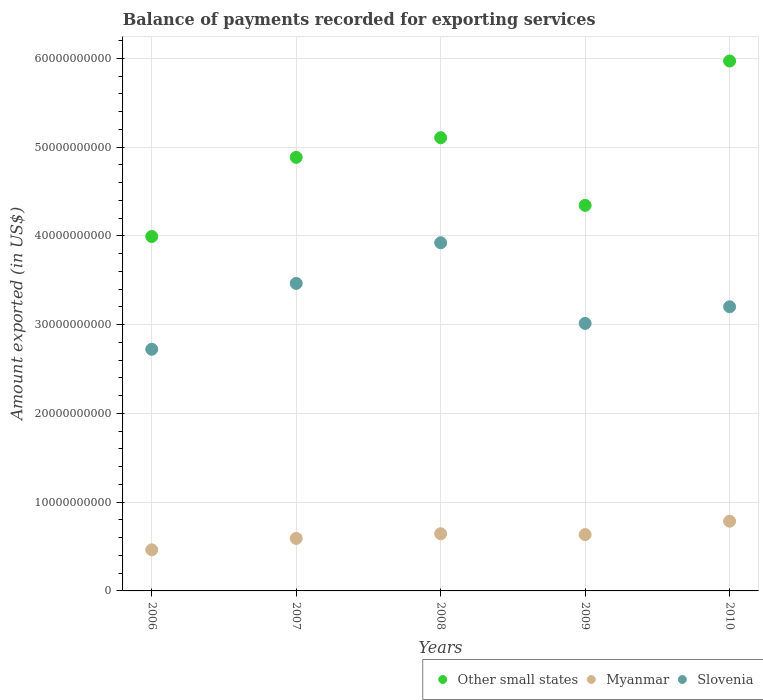Is the number of dotlines equal to the number of legend labels?
Make the answer very short. Yes. What is the amount exported in Myanmar in 2009?
Keep it short and to the point. 6.35e+09. Across all years, what is the maximum amount exported in Slovenia?
Give a very brief answer. 3.92e+1. Across all years, what is the minimum amount exported in Myanmar?
Offer a very short reply. 4.63e+09. What is the total amount exported in Myanmar in the graph?
Your answer should be compact. 3.12e+1. What is the difference between the amount exported in Other small states in 2008 and that in 2010?
Offer a terse response. -8.64e+09. What is the difference between the amount exported in Slovenia in 2009 and the amount exported in Other small states in 2007?
Your answer should be very brief. -1.87e+1. What is the average amount exported in Slovenia per year?
Your answer should be compact. 3.26e+1. In the year 2009, what is the difference between the amount exported in Other small states and amount exported in Myanmar?
Offer a very short reply. 3.71e+1. In how many years, is the amount exported in Other small states greater than 32000000000 US$?
Your answer should be compact. 5. What is the ratio of the amount exported in Myanmar in 2006 to that in 2007?
Keep it short and to the point. 0.78. Is the difference between the amount exported in Other small states in 2006 and 2007 greater than the difference between the amount exported in Myanmar in 2006 and 2007?
Your answer should be very brief. No. What is the difference between the highest and the second highest amount exported in Slovenia?
Make the answer very short. 4.58e+09. What is the difference between the highest and the lowest amount exported in Other small states?
Your answer should be compact. 1.98e+1. In how many years, is the amount exported in Slovenia greater than the average amount exported in Slovenia taken over all years?
Provide a succinct answer. 2. Does the amount exported in Myanmar monotonically increase over the years?
Your response must be concise. No. Is the amount exported in Slovenia strictly greater than the amount exported in Myanmar over the years?
Offer a terse response. Yes. Is the amount exported in Other small states strictly less than the amount exported in Myanmar over the years?
Provide a short and direct response. No. How many years are there in the graph?
Your answer should be very brief. 5. Does the graph contain any zero values?
Your response must be concise. No. Does the graph contain grids?
Ensure brevity in your answer.  Yes. Where does the legend appear in the graph?
Give a very brief answer. Bottom right. How are the legend labels stacked?
Ensure brevity in your answer.  Horizontal. What is the title of the graph?
Provide a short and direct response. Balance of payments recorded for exporting services. Does "Malaysia" appear as one of the legend labels in the graph?
Ensure brevity in your answer.  No. What is the label or title of the X-axis?
Give a very brief answer. Years. What is the label or title of the Y-axis?
Your answer should be compact. Amount exported (in US$). What is the Amount exported (in US$) of Other small states in 2006?
Your answer should be very brief. 3.99e+1. What is the Amount exported (in US$) of Myanmar in 2006?
Make the answer very short. 4.63e+09. What is the Amount exported (in US$) in Slovenia in 2006?
Offer a terse response. 2.72e+1. What is the Amount exported (in US$) of Other small states in 2007?
Your answer should be compact. 4.88e+1. What is the Amount exported (in US$) of Myanmar in 2007?
Keep it short and to the point. 5.91e+09. What is the Amount exported (in US$) in Slovenia in 2007?
Offer a very short reply. 3.46e+1. What is the Amount exported (in US$) in Other small states in 2008?
Provide a succinct answer. 5.11e+1. What is the Amount exported (in US$) in Myanmar in 2008?
Offer a very short reply. 6.44e+09. What is the Amount exported (in US$) of Slovenia in 2008?
Make the answer very short. 3.92e+1. What is the Amount exported (in US$) of Other small states in 2009?
Offer a very short reply. 4.34e+1. What is the Amount exported (in US$) of Myanmar in 2009?
Make the answer very short. 6.35e+09. What is the Amount exported (in US$) in Slovenia in 2009?
Your response must be concise. 3.01e+1. What is the Amount exported (in US$) of Other small states in 2010?
Offer a terse response. 5.97e+1. What is the Amount exported (in US$) of Myanmar in 2010?
Offer a very short reply. 7.85e+09. What is the Amount exported (in US$) of Slovenia in 2010?
Offer a terse response. 3.20e+1. Across all years, what is the maximum Amount exported (in US$) of Other small states?
Your answer should be compact. 5.97e+1. Across all years, what is the maximum Amount exported (in US$) of Myanmar?
Keep it short and to the point. 7.85e+09. Across all years, what is the maximum Amount exported (in US$) of Slovenia?
Provide a succinct answer. 3.92e+1. Across all years, what is the minimum Amount exported (in US$) of Other small states?
Your answer should be compact. 3.99e+1. Across all years, what is the minimum Amount exported (in US$) of Myanmar?
Give a very brief answer. 4.63e+09. Across all years, what is the minimum Amount exported (in US$) in Slovenia?
Make the answer very short. 2.72e+1. What is the total Amount exported (in US$) of Other small states in the graph?
Provide a succinct answer. 2.43e+11. What is the total Amount exported (in US$) in Myanmar in the graph?
Keep it short and to the point. 3.12e+1. What is the total Amount exported (in US$) of Slovenia in the graph?
Make the answer very short. 1.63e+11. What is the difference between the Amount exported (in US$) in Other small states in 2006 and that in 2007?
Ensure brevity in your answer.  -8.91e+09. What is the difference between the Amount exported (in US$) of Myanmar in 2006 and that in 2007?
Your answer should be compact. -1.28e+09. What is the difference between the Amount exported (in US$) of Slovenia in 2006 and that in 2007?
Offer a very short reply. -7.42e+09. What is the difference between the Amount exported (in US$) in Other small states in 2006 and that in 2008?
Offer a very short reply. -1.11e+1. What is the difference between the Amount exported (in US$) in Myanmar in 2006 and that in 2008?
Provide a succinct answer. -1.81e+09. What is the difference between the Amount exported (in US$) in Slovenia in 2006 and that in 2008?
Make the answer very short. -1.20e+1. What is the difference between the Amount exported (in US$) of Other small states in 2006 and that in 2009?
Offer a very short reply. -3.51e+09. What is the difference between the Amount exported (in US$) in Myanmar in 2006 and that in 2009?
Your answer should be very brief. -1.72e+09. What is the difference between the Amount exported (in US$) in Slovenia in 2006 and that in 2009?
Keep it short and to the point. -2.91e+09. What is the difference between the Amount exported (in US$) of Other small states in 2006 and that in 2010?
Ensure brevity in your answer.  -1.98e+1. What is the difference between the Amount exported (in US$) of Myanmar in 2006 and that in 2010?
Offer a very short reply. -3.22e+09. What is the difference between the Amount exported (in US$) in Slovenia in 2006 and that in 2010?
Your answer should be very brief. -4.79e+09. What is the difference between the Amount exported (in US$) in Other small states in 2007 and that in 2008?
Give a very brief answer. -2.21e+09. What is the difference between the Amount exported (in US$) in Myanmar in 2007 and that in 2008?
Provide a short and direct response. -5.28e+08. What is the difference between the Amount exported (in US$) of Slovenia in 2007 and that in 2008?
Keep it short and to the point. -4.58e+09. What is the difference between the Amount exported (in US$) of Other small states in 2007 and that in 2009?
Your response must be concise. 5.41e+09. What is the difference between the Amount exported (in US$) of Myanmar in 2007 and that in 2009?
Your answer should be compact. -4.36e+08. What is the difference between the Amount exported (in US$) of Slovenia in 2007 and that in 2009?
Offer a terse response. 4.51e+09. What is the difference between the Amount exported (in US$) of Other small states in 2007 and that in 2010?
Provide a short and direct response. -1.09e+1. What is the difference between the Amount exported (in US$) in Myanmar in 2007 and that in 2010?
Your response must be concise. -1.94e+09. What is the difference between the Amount exported (in US$) in Slovenia in 2007 and that in 2010?
Your answer should be very brief. 2.63e+09. What is the difference between the Amount exported (in US$) in Other small states in 2008 and that in 2009?
Offer a very short reply. 7.62e+09. What is the difference between the Amount exported (in US$) of Myanmar in 2008 and that in 2009?
Offer a terse response. 9.17e+07. What is the difference between the Amount exported (in US$) of Slovenia in 2008 and that in 2009?
Give a very brief answer. 9.09e+09. What is the difference between the Amount exported (in US$) in Other small states in 2008 and that in 2010?
Make the answer very short. -8.64e+09. What is the difference between the Amount exported (in US$) of Myanmar in 2008 and that in 2010?
Keep it short and to the point. -1.41e+09. What is the difference between the Amount exported (in US$) of Slovenia in 2008 and that in 2010?
Keep it short and to the point. 7.21e+09. What is the difference between the Amount exported (in US$) of Other small states in 2009 and that in 2010?
Your answer should be very brief. -1.63e+1. What is the difference between the Amount exported (in US$) in Myanmar in 2009 and that in 2010?
Keep it short and to the point. -1.50e+09. What is the difference between the Amount exported (in US$) in Slovenia in 2009 and that in 2010?
Offer a very short reply. -1.88e+09. What is the difference between the Amount exported (in US$) of Other small states in 2006 and the Amount exported (in US$) of Myanmar in 2007?
Provide a succinct answer. 3.40e+1. What is the difference between the Amount exported (in US$) of Other small states in 2006 and the Amount exported (in US$) of Slovenia in 2007?
Your answer should be compact. 5.29e+09. What is the difference between the Amount exported (in US$) of Myanmar in 2006 and the Amount exported (in US$) of Slovenia in 2007?
Ensure brevity in your answer.  -3.00e+1. What is the difference between the Amount exported (in US$) in Other small states in 2006 and the Amount exported (in US$) in Myanmar in 2008?
Your response must be concise. 3.35e+1. What is the difference between the Amount exported (in US$) of Other small states in 2006 and the Amount exported (in US$) of Slovenia in 2008?
Your answer should be very brief. 7.07e+08. What is the difference between the Amount exported (in US$) in Myanmar in 2006 and the Amount exported (in US$) in Slovenia in 2008?
Your answer should be very brief. -3.46e+1. What is the difference between the Amount exported (in US$) of Other small states in 2006 and the Amount exported (in US$) of Myanmar in 2009?
Offer a terse response. 3.36e+1. What is the difference between the Amount exported (in US$) of Other small states in 2006 and the Amount exported (in US$) of Slovenia in 2009?
Provide a short and direct response. 9.79e+09. What is the difference between the Amount exported (in US$) in Myanmar in 2006 and the Amount exported (in US$) in Slovenia in 2009?
Your response must be concise. -2.55e+1. What is the difference between the Amount exported (in US$) in Other small states in 2006 and the Amount exported (in US$) in Myanmar in 2010?
Give a very brief answer. 3.21e+1. What is the difference between the Amount exported (in US$) in Other small states in 2006 and the Amount exported (in US$) in Slovenia in 2010?
Make the answer very short. 7.92e+09. What is the difference between the Amount exported (in US$) of Myanmar in 2006 and the Amount exported (in US$) of Slovenia in 2010?
Ensure brevity in your answer.  -2.74e+1. What is the difference between the Amount exported (in US$) in Other small states in 2007 and the Amount exported (in US$) in Myanmar in 2008?
Keep it short and to the point. 4.24e+1. What is the difference between the Amount exported (in US$) of Other small states in 2007 and the Amount exported (in US$) of Slovenia in 2008?
Keep it short and to the point. 9.62e+09. What is the difference between the Amount exported (in US$) of Myanmar in 2007 and the Amount exported (in US$) of Slovenia in 2008?
Your answer should be very brief. -3.33e+1. What is the difference between the Amount exported (in US$) of Other small states in 2007 and the Amount exported (in US$) of Myanmar in 2009?
Offer a very short reply. 4.25e+1. What is the difference between the Amount exported (in US$) of Other small states in 2007 and the Amount exported (in US$) of Slovenia in 2009?
Provide a succinct answer. 1.87e+1. What is the difference between the Amount exported (in US$) in Myanmar in 2007 and the Amount exported (in US$) in Slovenia in 2009?
Ensure brevity in your answer.  -2.42e+1. What is the difference between the Amount exported (in US$) of Other small states in 2007 and the Amount exported (in US$) of Myanmar in 2010?
Keep it short and to the point. 4.10e+1. What is the difference between the Amount exported (in US$) in Other small states in 2007 and the Amount exported (in US$) in Slovenia in 2010?
Ensure brevity in your answer.  1.68e+1. What is the difference between the Amount exported (in US$) of Myanmar in 2007 and the Amount exported (in US$) of Slovenia in 2010?
Your response must be concise. -2.61e+1. What is the difference between the Amount exported (in US$) in Other small states in 2008 and the Amount exported (in US$) in Myanmar in 2009?
Provide a succinct answer. 4.47e+1. What is the difference between the Amount exported (in US$) of Other small states in 2008 and the Amount exported (in US$) of Slovenia in 2009?
Make the answer very short. 2.09e+1. What is the difference between the Amount exported (in US$) in Myanmar in 2008 and the Amount exported (in US$) in Slovenia in 2009?
Your response must be concise. -2.37e+1. What is the difference between the Amount exported (in US$) in Other small states in 2008 and the Amount exported (in US$) in Myanmar in 2010?
Make the answer very short. 4.32e+1. What is the difference between the Amount exported (in US$) of Other small states in 2008 and the Amount exported (in US$) of Slovenia in 2010?
Offer a very short reply. 1.90e+1. What is the difference between the Amount exported (in US$) in Myanmar in 2008 and the Amount exported (in US$) in Slovenia in 2010?
Make the answer very short. -2.56e+1. What is the difference between the Amount exported (in US$) of Other small states in 2009 and the Amount exported (in US$) of Myanmar in 2010?
Give a very brief answer. 3.56e+1. What is the difference between the Amount exported (in US$) of Other small states in 2009 and the Amount exported (in US$) of Slovenia in 2010?
Keep it short and to the point. 1.14e+1. What is the difference between the Amount exported (in US$) of Myanmar in 2009 and the Amount exported (in US$) of Slovenia in 2010?
Keep it short and to the point. -2.57e+1. What is the average Amount exported (in US$) in Other small states per year?
Make the answer very short. 4.86e+1. What is the average Amount exported (in US$) of Myanmar per year?
Keep it short and to the point. 6.24e+09. What is the average Amount exported (in US$) of Slovenia per year?
Provide a short and direct response. 3.26e+1. In the year 2006, what is the difference between the Amount exported (in US$) in Other small states and Amount exported (in US$) in Myanmar?
Offer a terse response. 3.53e+1. In the year 2006, what is the difference between the Amount exported (in US$) of Other small states and Amount exported (in US$) of Slovenia?
Your answer should be very brief. 1.27e+1. In the year 2006, what is the difference between the Amount exported (in US$) of Myanmar and Amount exported (in US$) of Slovenia?
Keep it short and to the point. -2.26e+1. In the year 2007, what is the difference between the Amount exported (in US$) of Other small states and Amount exported (in US$) of Myanmar?
Give a very brief answer. 4.29e+1. In the year 2007, what is the difference between the Amount exported (in US$) in Other small states and Amount exported (in US$) in Slovenia?
Provide a short and direct response. 1.42e+1. In the year 2007, what is the difference between the Amount exported (in US$) in Myanmar and Amount exported (in US$) in Slovenia?
Offer a very short reply. -2.87e+1. In the year 2008, what is the difference between the Amount exported (in US$) of Other small states and Amount exported (in US$) of Myanmar?
Provide a short and direct response. 4.46e+1. In the year 2008, what is the difference between the Amount exported (in US$) in Other small states and Amount exported (in US$) in Slovenia?
Ensure brevity in your answer.  1.18e+1. In the year 2008, what is the difference between the Amount exported (in US$) of Myanmar and Amount exported (in US$) of Slovenia?
Your answer should be very brief. -3.28e+1. In the year 2009, what is the difference between the Amount exported (in US$) in Other small states and Amount exported (in US$) in Myanmar?
Your answer should be very brief. 3.71e+1. In the year 2009, what is the difference between the Amount exported (in US$) of Other small states and Amount exported (in US$) of Slovenia?
Ensure brevity in your answer.  1.33e+1. In the year 2009, what is the difference between the Amount exported (in US$) of Myanmar and Amount exported (in US$) of Slovenia?
Give a very brief answer. -2.38e+1. In the year 2010, what is the difference between the Amount exported (in US$) of Other small states and Amount exported (in US$) of Myanmar?
Offer a very short reply. 5.18e+1. In the year 2010, what is the difference between the Amount exported (in US$) of Other small states and Amount exported (in US$) of Slovenia?
Ensure brevity in your answer.  2.77e+1. In the year 2010, what is the difference between the Amount exported (in US$) of Myanmar and Amount exported (in US$) of Slovenia?
Offer a terse response. -2.42e+1. What is the ratio of the Amount exported (in US$) in Other small states in 2006 to that in 2007?
Provide a short and direct response. 0.82. What is the ratio of the Amount exported (in US$) in Myanmar in 2006 to that in 2007?
Ensure brevity in your answer.  0.78. What is the ratio of the Amount exported (in US$) of Slovenia in 2006 to that in 2007?
Give a very brief answer. 0.79. What is the ratio of the Amount exported (in US$) of Other small states in 2006 to that in 2008?
Provide a short and direct response. 0.78. What is the ratio of the Amount exported (in US$) of Myanmar in 2006 to that in 2008?
Your answer should be very brief. 0.72. What is the ratio of the Amount exported (in US$) in Slovenia in 2006 to that in 2008?
Your answer should be compact. 0.69. What is the ratio of the Amount exported (in US$) in Other small states in 2006 to that in 2009?
Keep it short and to the point. 0.92. What is the ratio of the Amount exported (in US$) of Myanmar in 2006 to that in 2009?
Provide a succinct answer. 0.73. What is the ratio of the Amount exported (in US$) in Slovenia in 2006 to that in 2009?
Your answer should be compact. 0.9. What is the ratio of the Amount exported (in US$) of Other small states in 2006 to that in 2010?
Ensure brevity in your answer.  0.67. What is the ratio of the Amount exported (in US$) in Myanmar in 2006 to that in 2010?
Offer a very short reply. 0.59. What is the ratio of the Amount exported (in US$) of Slovenia in 2006 to that in 2010?
Offer a very short reply. 0.85. What is the ratio of the Amount exported (in US$) of Other small states in 2007 to that in 2008?
Ensure brevity in your answer.  0.96. What is the ratio of the Amount exported (in US$) in Myanmar in 2007 to that in 2008?
Provide a short and direct response. 0.92. What is the ratio of the Amount exported (in US$) of Slovenia in 2007 to that in 2008?
Offer a very short reply. 0.88. What is the ratio of the Amount exported (in US$) in Other small states in 2007 to that in 2009?
Offer a very short reply. 1.12. What is the ratio of the Amount exported (in US$) of Myanmar in 2007 to that in 2009?
Your answer should be very brief. 0.93. What is the ratio of the Amount exported (in US$) in Slovenia in 2007 to that in 2009?
Give a very brief answer. 1.15. What is the ratio of the Amount exported (in US$) of Other small states in 2007 to that in 2010?
Offer a terse response. 0.82. What is the ratio of the Amount exported (in US$) in Myanmar in 2007 to that in 2010?
Ensure brevity in your answer.  0.75. What is the ratio of the Amount exported (in US$) of Slovenia in 2007 to that in 2010?
Keep it short and to the point. 1.08. What is the ratio of the Amount exported (in US$) in Other small states in 2008 to that in 2009?
Make the answer very short. 1.18. What is the ratio of the Amount exported (in US$) in Myanmar in 2008 to that in 2009?
Offer a terse response. 1.01. What is the ratio of the Amount exported (in US$) in Slovenia in 2008 to that in 2009?
Make the answer very short. 1.3. What is the ratio of the Amount exported (in US$) in Other small states in 2008 to that in 2010?
Keep it short and to the point. 0.86. What is the ratio of the Amount exported (in US$) of Myanmar in 2008 to that in 2010?
Your answer should be very brief. 0.82. What is the ratio of the Amount exported (in US$) in Slovenia in 2008 to that in 2010?
Give a very brief answer. 1.23. What is the ratio of the Amount exported (in US$) of Other small states in 2009 to that in 2010?
Ensure brevity in your answer.  0.73. What is the ratio of the Amount exported (in US$) of Myanmar in 2009 to that in 2010?
Keep it short and to the point. 0.81. What is the ratio of the Amount exported (in US$) of Slovenia in 2009 to that in 2010?
Your answer should be very brief. 0.94. What is the difference between the highest and the second highest Amount exported (in US$) in Other small states?
Keep it short and to the point. 8.64e+09. What is the difference between the highest and the second highest Amount exported (in US$) of Myanmar?
Your answer should be very brief. 1.41e+09. What is the difference between the highest and the second highest Amount exported (in US$) of Slovenia?
Your response must be concise. 4.58e+09. What is the difference between the highest and the lowest Amount exported (in US$) in Other small states?
Provide a short and direct response. 1.98e+1. What is the difference between the highest and the lowest Amount exported (in US$) in Myanmar?
Give a very brief answer. 3.22e+09. What is the difference between the highest and the lowest Amount exported (in US$) of Slovenia?
Keep it short and to the point. 1.20e+1. 